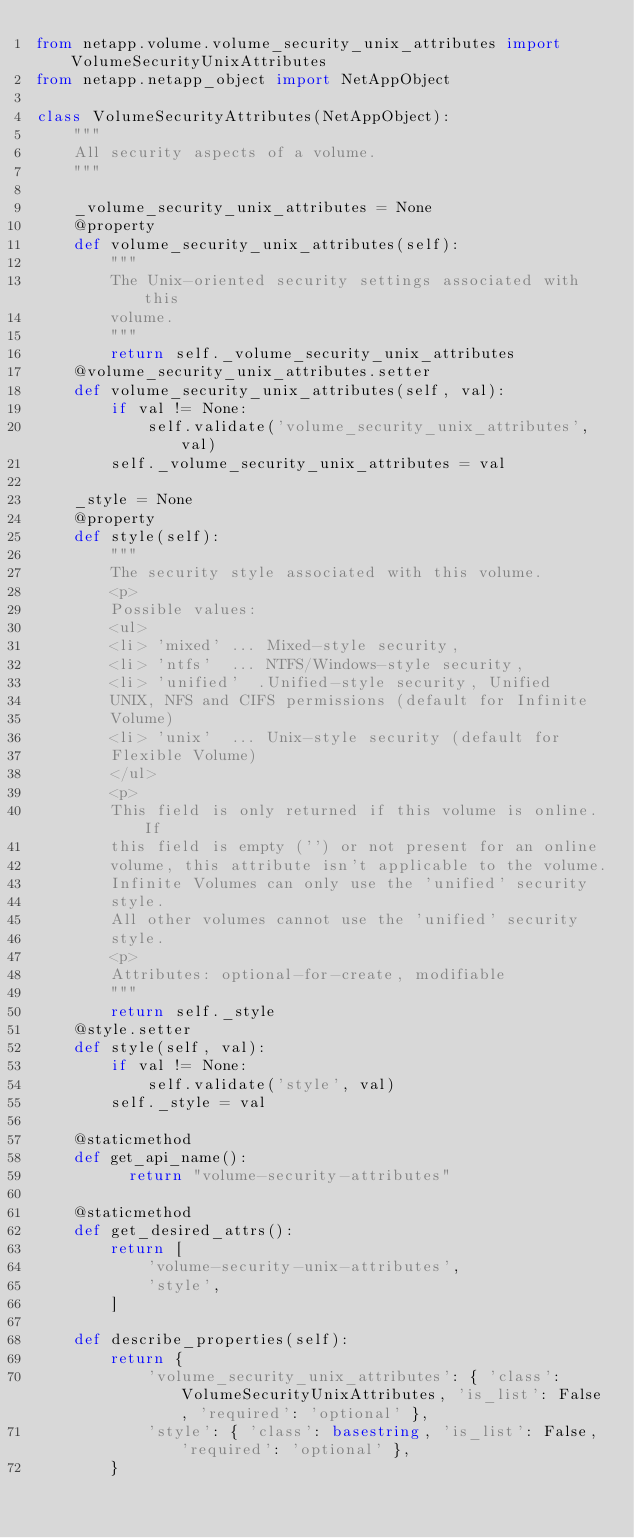Convert code to text. <code><loc_0><loc_0><loc_500><loc_500><_Python_>from netapp.volume.volume_security_unix_attributes import VolumeSecurityUnixAttributes
from netapp.netapp_object import NetAppObject

class VolumeSecurityAttributes(NetAppObject):
    """
    All security aspects of a volume.
    """
    
    _volume_security_unix_attributes = None
    @property
    def volume_security_unix_attributes(self):
        """
        The Unix-oriented security settings associated with this
        volume.
        """
        return self._volume_security_unix_attributes
    @volume_security_unix_attributes.setter
    def volume_security_unix_attributes(self, val):
        if val != None:
            self.validate('volume_security_unix_attributes', val)
        self._volume_security_unix_attributes = val
    
    _style = None
    @property
    def style(self):
        """
        The security style associated with this volume.
        <p>
        Possible values:
        <ul>
        <li> 'mixed' ... Mixed-style security,
        <li> 'ntfs'  ... NTFS/Windows-style security,
        <li> 'unified'  .Unified-style security, Unified
        UNIX, NFS and CIFS permissions (default for Infinite
        Volume)
        <li> 'unix'  ... Unix-style security (default for
        Flexible Volume)
        </ul>
        <p>
        This field is only returned if this volume is online. If
        this field is empty ('') or not present for an online
        volume, this attribute isn't applicable to the volume.
        Infinite Volumes can only use the 'unified' security
        style.
        All other volumes cannot use the 'unified' security
        style.
        <p>
        Attributes: optional-for-create, modifiable
        """
        return self._style
    @style.setter
    def style(self, val):
        if val != None:
            self.validate('style', val)
        self._style = val
    
    @staticmethod
    def get_api_name():
          return "volume-security-attributes"
    
    @staticmethod
    def get_desired_attrs():
        return [
            'volume-security-unix-attributes',
            'style',
        ]
    
    def describe_properties(self):
        return {
            'volume_security_unix_attributes': { 'class': VolumeSecurityUnixAttributes, 'is_list': False, 'required': 'optional' },
            'style': { 'class': basestring, 'is_list': False, 'required': 'optional' },
        }
</code> 